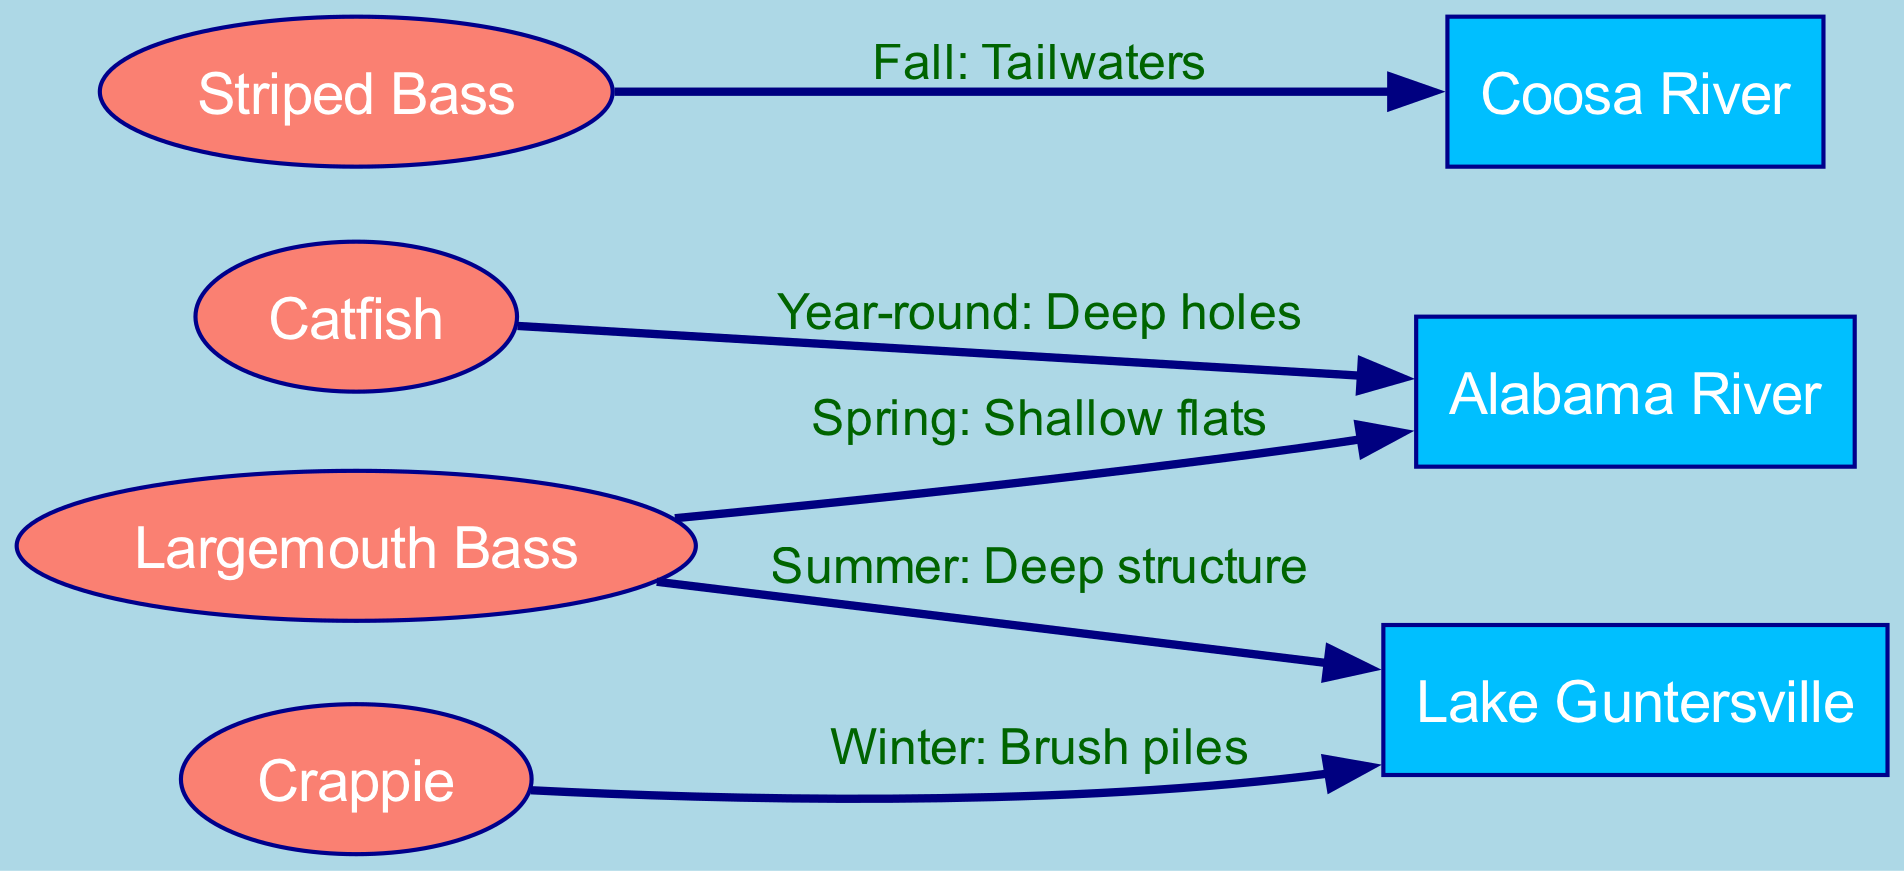What fish is associated with shalow flats in the Alabama River? The diagram indicates that Largemouth Bass are found in shallow flats of the Alabama River during Spring. You can see the edge connecting the Largemouth Bass node to the Alabama River node labeled with "Spring: Shallow flats."
Answer: Largemouth Bass Which water body is linked to Crappie in winter? According to the diagram, Crappie are associated with Lake Guntersville during Winter. This is shown by the edge connecting the Crappie node to the Lake Guntersville node accompanied by the label "Winter: Brush piles."
Answer: Lake Guntersville How many game fish species are represented in the diagram? The diagram displays a total of four game fish species: Largemouth Bass, Striped Bass, Crappie, and Catfish. By counting the fish nodes, you can confirm this number.
Answer: Four What is the best season for Striped Bass in the Coosa River? The diagram illustrates that the best season for fishing Striped Bass in the Coosa River is Fall, as indicated by the label on the edge connecting the Striped Bass node and the Coosa River node.
Answer: Fall What seasonal fishing spot is recommended for Largemouth Bass? The diagram notes that in Spring, Largemouth Bass are best found in shallow flats within the Alabama River, as indicated by the connecting edge between these two nodes.
Answer: Shallow flats Which type of fish can be found year-round in the Alabama River? From the diagram, it's clear that Catfish can be found year-round in the deep holes of the Alabama River. This is evidenced by the edge labeled "Year-round: Deep holes" connecting the Catfish to the Alabama River.
Answer: Catfish In which season are Crappies found in Lake Guntersville? The diagram specifies that Crappies are found in winter around brush piles in Lake Guntersville, as shown by the edge connecting these two nodes with the appropriate label.
Answer: Winter What is the best fishing spot for Largemouth Bass during summer? The diagram indicates that during summer, Largemouth Bass can be fished around deep structure in Lake Guntersville, as denoted by the edge connecting these two nodes.
Answer: Deep structure 